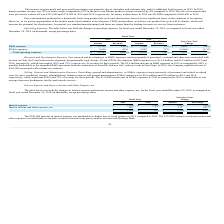From Quicklogic Corporation's financial document, What are the respective interest expense in 2018 and 2019? The document shows two values: 108 and 350 (in thousands). From the document: "Interest expense $ (350 ) $ (108 ) $ (242 ) 224 % R&D expenses $ 12,350 120 % $ 9,948 79 % $ 2,402 24 %..." Also, What are the respective net values of interest income and other expenses in 2018 and 2019? The document shows two values: 77 and 189 (in thousands). From the document: "Interest income and other expense, net 189 77 112 145 % Interest income and other expense, net 189 77 112 145 %..." Also, What is the increase in interest expense between 2018 and 2019? According to the financial document, $242,000. The relevant text states: "The $242,000 increase in interest expense was attributable to higher line of credit balance in 2019 compared to 2..." Also, can you calculate: What is the average interest expense in 2018 and 2019? To answer this question, I need to perform calculations using the financial data. The calculation is: (108 + 350)/2 , which equals 229 (in thousands). This is based on the information: "Interest expense $ (350 ) $ (108 ) $ (242 ) 224 % R&D expenses $ 12,350 120 % $ 9,948 79 % $ 2,402 24 %..." The key data points involved are: 108, 350. Also, can you calculate: What is the average net interest income and other expense in 2018 and 2019? To answer this question, I need to perform calculations using the financial data. The calculation is: (77 + 189)/2 , which equals 133 (in thousands). This is based on the information: "Interest income and other expense, net 189 77 112 145 % Interest income and other expense, net 189 77 112 145 %..." The key data points involved are: 189, 77. Also, can you calculate: What is the average total interest expense and interest income and other expense, net, in 2018 and 2019? To answer this question, I need to perform calculations using the financial data. The calculation is: -(31 + 161)/2 , which equals -96 (in thousands). This is based on the information: "$ (161 ) $ (31) $ (130 ) 419 % $ (161 ) $ (31) $ (130 ) 419 %..." The key data points involved are: 161, 31. 